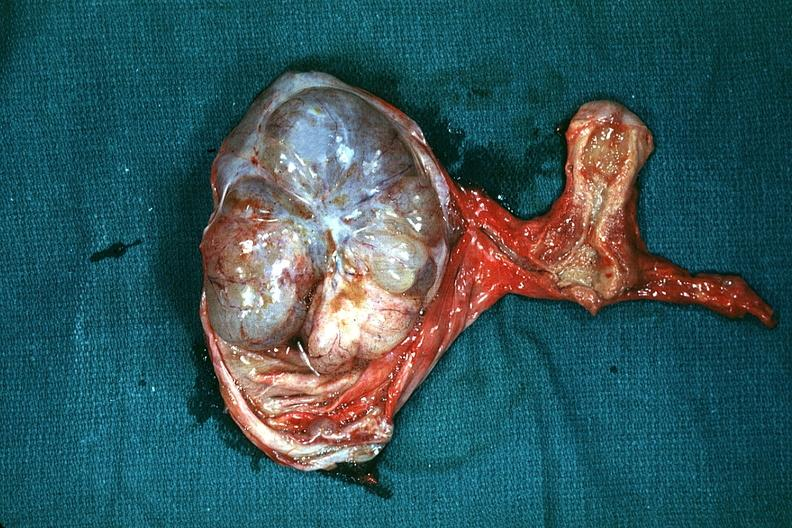s female reproductive present?
Answer the question using a single word or phrase. Yes 